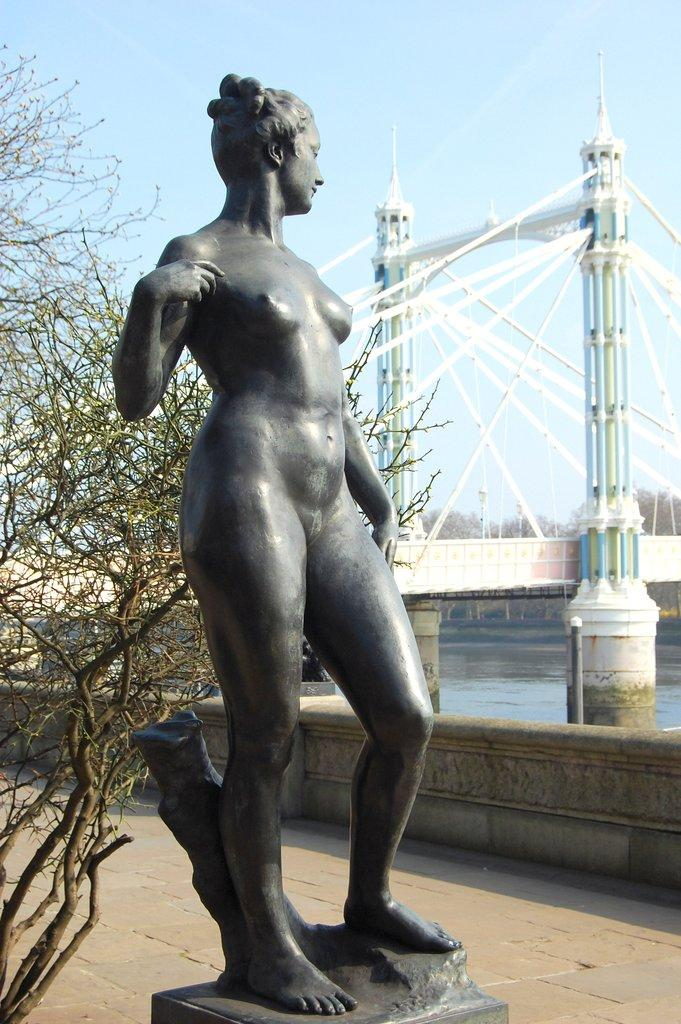What is the main subject of the image? There is a statue in the image. How is the statue positioned in the image? The statue is on a pedestal. What other natural elements can be seen in the image? There is a tree, a river, and trees in the background of the image. What architectural feature is present in the image? There is a bridge in the image. What is visible on the ground in the image? The floor is visible in the image. What part of the natural environment is visible in the background of the image? The sky is visible in the background of the image. What type of yak can be seen grazing on the grass near the statue in the image? There is no yak present in the image; it only features a statue, a tree, a river, a bridge, the floor, and the sky. How does the statue affect the acoustics of the surrounding area in the image? The statue's impact on the acoustics of the surrounding area cannot be determined from the image alone, as it does not provide information about the sound environment. 